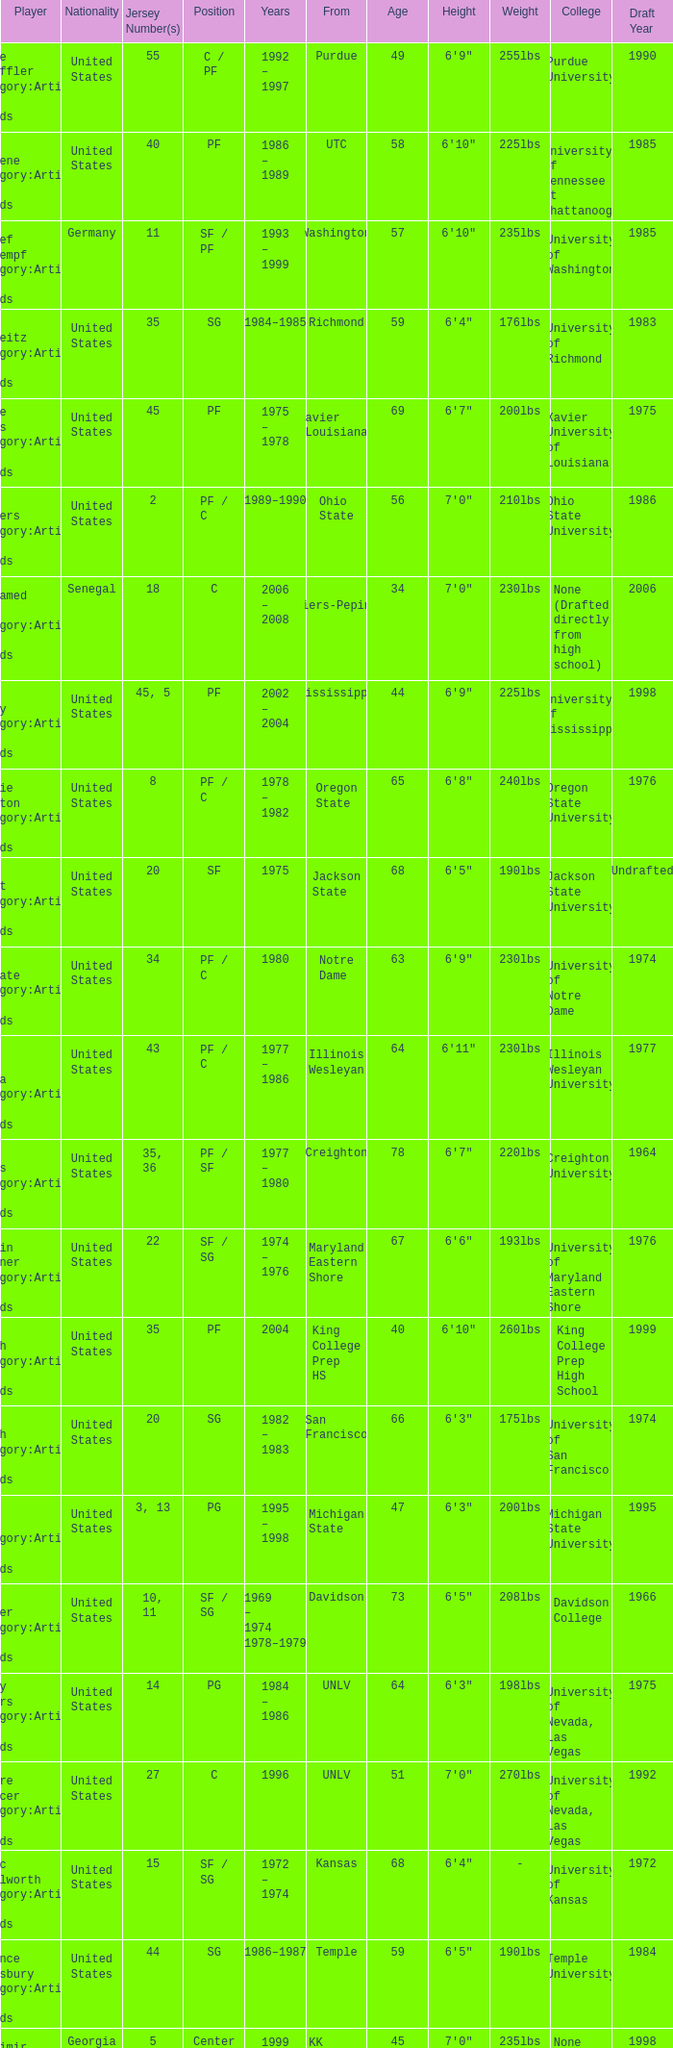What position does the player with jersey number 22 play? SF / SG. 